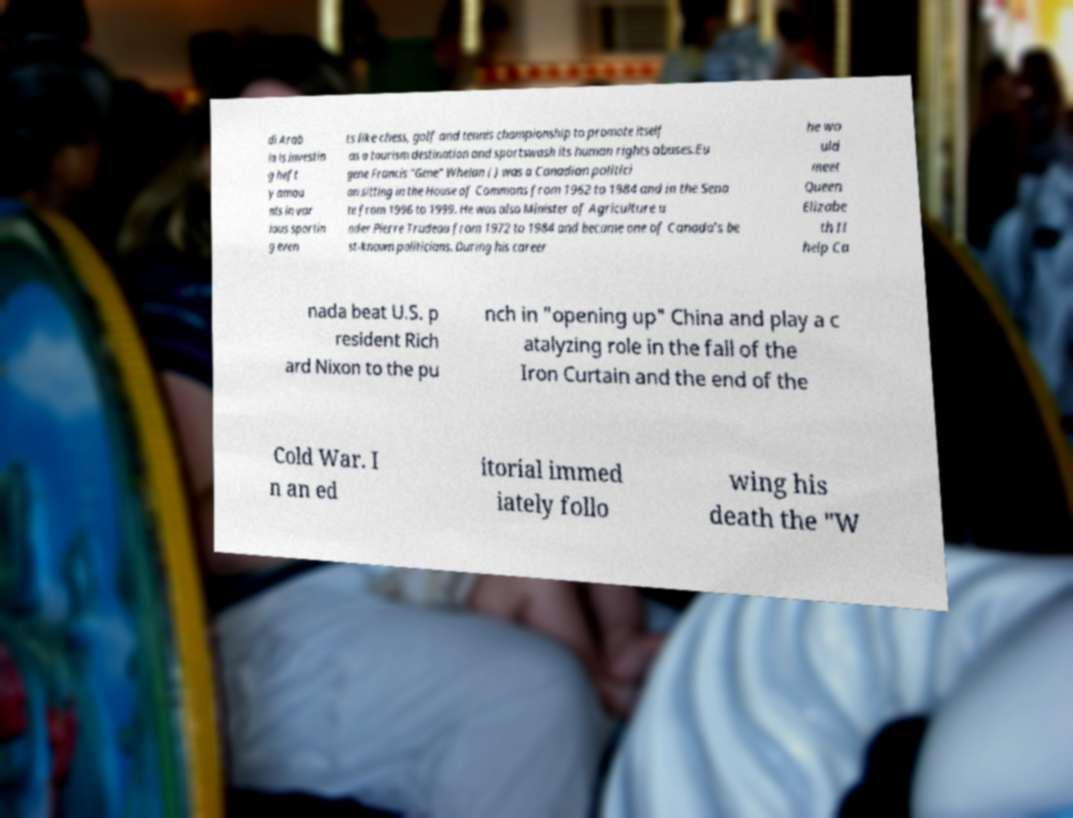There's text embedded in this image that I need extracted. Can you transcribe it verbatim? di Arab ia is investin g heft y amou nts in var ious sportin g even ts like chess, golf and tennis championship to promote itself as a tourism destination and sportswash its human rights abuses.Eu gene Francis "Gene" Whelan ( ) was a Canadian politici an sitting in the House of Commons from 1962 to 1984 and in the Sena te from 1996 to 1999. He was also Minister of Agriculture u nder Pierre Trudeau from 1972 to 1984 and became one of Canada's be st-known politicians. During his career he wo uld meet Queen Elizabe th II help Ca nada beat U.S. p resident Rich ard Nixon to the pu nch in "opening up" China and play a c atalyzing role in the fall of the Iron Curtain and the end of the Cold War. I n an ed itorial immed iately follo wing his death the "W 